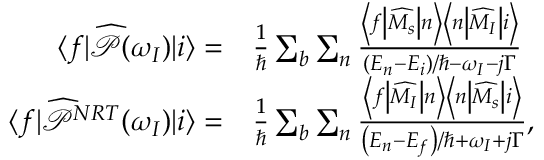<formula> <loc_0><loc_0><loc_500><loc_500>\begin{array} { r l } { \langle f | \widehat { \mathcal { P } } ( \omega _ { I } ) | i \rangle = } & { \frac { 1 } { } \sum _ { b } \sum _ { n } \frac { \left < f | d l e | \widehat { M _ { s } } | d l e | n \right > \left < n | d l e | \widehat { M _ { I } } | d l e | i \right > } { \left ( E _ { n } - E _ { i } \right ) / \hbar { - } \omega _ { I } - j \Gamma } } \\ { \langle f | \widehat { \mathcal { P } } ^ { N R T } ( \omega _ { I } ) | i \rangle = } & { \frac { 1 } { } \sum _ { b } \sum _ { n } \frac { \left < f | d l e | \widehat { M _ { I } } | d l e | n \right > \left < n | d l e | \widehat { M _ { s } } | d l e | i \right > } { \left ( E _ { n } - E _ { f } \right ) / \hbar { + } \omega _ { I } + j \Gamma } , } \end{array}</formula> 